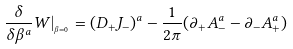Convert formula to latex. <formula><loc_0><loc_0><loc_500><loc_500>\frac { \delta } { \delta \beta ^ { a } } W | _ { _ { \beta = 0 } } = ( D _ { + } J _ { - } ) ^ { a } - \frac { 1 } { 2 \pi } ( \partial _ { + } A _ { - } ^ { a } - \partial _ { - } A _ { + } ^ { a } )</formula> 